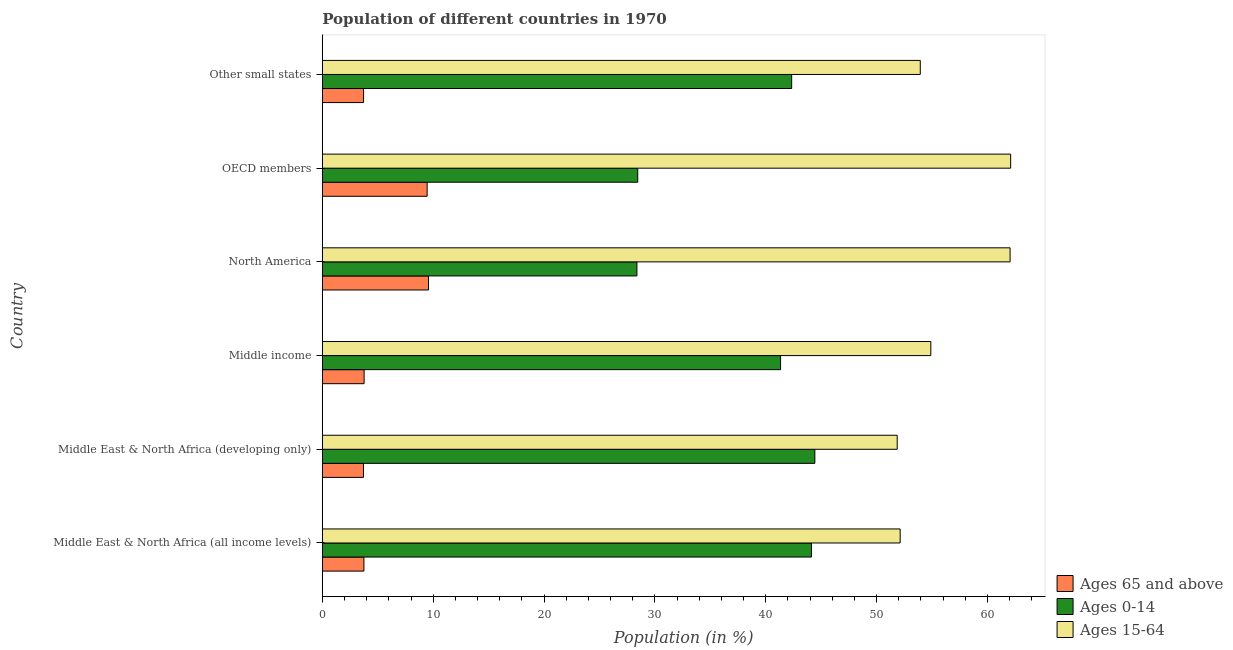How many different coloured bars are there?
Offer a terse response. 3. Are the number of bars on each tick of the Y-axis equal?
Offer a terse response. Yes. What is the label of the 3rd group of bars from the top?
Your response must be concise. North America. What is the percentage of population within the age-group 15-64 in Middle East & North Africa (all income levels)?
Your answer should be very brief. 52.13. Across all countries, what is the maximum percentage of population within the age-group 15-64?
Provide a short and direct response. 62.09. Across all countries, what is the minimum percentage of population within the age-group of 65 and above?
Your answer should be compact. 3.71. In which country was the percentage of population within the age-group of 65 and above minimum?
Provide a short and direct response. Middle East & North Africa (developing only). What is the total percentage of population within the age-group 15-64 in the graph?
Give a very brief answer. 336.96. What is the difference between the percentage of population within the age-group 0-14 in Middle East & North Africa (developing only) and that in North America?
Give a very brief answer. 16.05. What is the difference between the percentage of population within the age-group of 65 and above in Middle income and the percentage of population within the age-group 0-14 in North America?
Keep it short and to the point. -24.61. What is the average percentage of population within the age-group 15-64 per country?
Provide a succinct answer. 56.16. What is the difference between the percentage of population within the age-group of 65 and above and percentage of population within the age-group 0-14 in Other small states?
Provide a short and direct response. -38.62. What is the ratio of the percentage of population within the age-group 15-64 in Middle East & North Africa (all income levels) to that in OECD members?
Your answer should be very brief. 0.84. What is the difference between the highest and the second highest percentage of population within the age-group 15-64?
Provide a succinct answer. 0.05. What is the difference between the highest and the lowest percentage of population within the age-group 0-14?
Your answer should be compact. 16.05. In how many countries, is the percentage of population within the age-group of 65 and above greater than the average percentage of population within the age-group of 65 and above taken over all countries?
Provide a succinct answer. 2. Is the sum of the percentage of population within the age-group 0-14 in Middle East & North Africa (all income levels) and Middle East & North Africa (developing only) greater than the maximum percentage of population within the age-group of 65 and above across all countries?
Ensure brevity in your answer.  Yes. What does the 1st bar from the top in Other small states represents?
Provide a short and direct response. Ages 15-64. What does the 3rd bar from the bottom in Middle East & North Africa (developing only) represents?
Provide a succinct answer. Ages 15-64. Is it the case that in every country, the sum of the percentage of population within the age-group of 65 and above and percentage of population within the age-group 0-14 is greater than the percentage of population within the age-group 15-64?
Ensure brevity in your answer.  No. Are all the bars in the graph horizontal?
Provide a short and direct response. Yes. What is the difference between two consecutive major ticks on the X-axis?
Your answer should be very brief. 10. Does the graph contain any zero values?
Give a very brief answer. No. Where does the legend appear in the graph?
Provide a succinct answer. Bottom right. How many legend labels are there?
Your answer should be compact. 3. What is the title of the graph?
Your response must be concise. Population of different countries in 1970. What is the label or title of the X-axis?
Keep it short and to the point. Population (in %). What is the label or title of the Y-axis?
Make the answer very short. Country. What is the Population (in %) of Ages 65 and above in Middle East & North Africa (all income levels)?
Offer a very short reply. 3.75. What is the Population (in %) in Ages 0-14 in Middle East & North Africa (all income levels)?
Provide a short and direct response. 44.12. What is the Population (in %) in Ages 15-64 in Middle East & North Africa (all income levels)?
Keep it short and to the point. 52.13. What is the Population (in %) in Ages 65 and above in Middle East & North Africa (developing only)?
Give a very brief answer. 3.71. What is the Population (in %) in Ages 0-14 in Middle East & North Africa (developing only)?
Provide a short and direct response. 44.43. What is the Population (in %) in Ages 15-64 in Middle East & North Africa (developing only)?
Make the answer very short. 51.86. What is the Population (in %) in Ages 65 and above in Middle income?
Provide a short and direct response. 3.77. What is the Population (in %) in Ages 0-14 in Middle income?
Your answer should be very brief. 41.34. What is the Population (in %) in Ages 15-64 in Middle income?
Ensure brevity in your answer.  54.89. What is the Population (in %) of Ages 65 and above in North America?
Provide a short and direct response. 9.58. What is the Population (in %) of Ages 0-14 in North America?
Your response must be concise. 28.38. What is the Population (in %) of Ages 15-64 in North America?
Provide a succinct answer. 62.04. What is the Population (in %) in Ages 65 and above in OECD members?
Provide a succinct answer. 9.45. What is the Population (in %) in Ages 0-14 in OECD members?
Make the answer very short. 28.45. What is the Population (in %) in Ages 15-64 in OECD members?
Make the answer very short. 62.09. What is the Population (in %) of Ages 65 and above in Other small states?
Offer a very short reply. 3.72. What is the Population (in %) of Ages 0-14 in Other small states?
Give a very brief answer. 42.34. What is the Population (in %) of Ages 15-64 in Other small states?
Provide a short and direct response. 53.94. Across all countries, what is the maximum Population (in %) of Ages 65 and above?
Make the answer very short. 9.58. Across all countries, what is the maximum Population (in %) in Ages 0-14?
Keep it short and to the point. 44.43. Across all countries, what is the maximum Population (in %) of Ages 15-64?
Make the answer very short. 62.09. Across all countries, what is the minimum Population (in %) in Ages 65 and above?
Ensure brevity in your answer.  3.71. Across all countries, what is the minimum Population (in %) of Ages 0-14?
Ensure brevity in your answer.  28.38. Across all countries, what is the minimum Population (in %) of Ages 15-64?
Keep it short and to the point. 51.86. What is the total Population (in %) of Ages 65 and above in the graph?
Keep it short and to the point. 33.98. What is the total Population (in %) of Ages 0-14 in the graph?
Keep it short and to the point. 229.06. What is the total Population (in %) in Ages 15-64 in the graph?
Give a very brief answer. 336.96. What is the difference between the Population (in %) of Ages 65 and above in Middle East & North Africa (all income levels) and that in Middle East & North Africa (developing only)?
Provide a short and direct response. 0.04. What is the difference between the Population (in %) of Ages 0-14 in Middle East & North Africa (all income levels) and that in Middle East & North Africa (developing only)?
Offer a very short reply. -0.31. What is the difference between the Population (in %) in Ages 15-64 in Middle East & North Africa (all income levels) and that in Middle East & North Africa (developing only)?
Your answer should be very brief. 0.27. What is the difference between the Population (in %) of Ages 65 and above in Middle East & North Africa (all income levels) and that in Middle income?
Your answer should be compact. -0.02. What is the difference between the Population (in %) of Ages 0-14 in Middle East & North Africa (all income levels) and that in Middle income?
Ensure brevity in your answer.  2.79. What is the difference between the Population (in %) of Ages 15-64 in Middle East & North Africa (all income levels) and that in Middle income?
Ensure brevity in your answer.  -2.77. What is the difference between the Population (in %) in Ages 65 and above in Middle East & North Africa (all income levels) and that in North America?
Your response must be concise. -5.83. What is the difference between the Population (in %) in Ages 0-14 in Middle East & North Africa (all income levels) and that in North America?
Provide a succinct answer. 15.74. What is the difference between the Population (in %) in Ages 15-64 in Middle East & North Africa (all income levels) and that in North America?
Your response must be concise. -9.92. What is the difference between the Population (in %) of Ages 65 and above in Middle East & North Africa (all income levels) and that in OECD members?
Keep it short and to the point. -5.7. What is the difference between the Population (in %) of Ages 0-14 in Middle East & North Africa (all income levels) and that in OECD members?
Provide a short and direct response. 15.67. What is the difference between the Population (in %) in Ages 15-64 in Middle East & North Africa (all income levels) and that in OECD members?
Provide a short and direct response. -9.97. What is the difference between the Population (in %) of Ages 65 and above in Middle East & North Africa (all income levels) and that in Other small states?
Offer a very short reply. 0.03. What is the difference between the Population (in %) in Ages 0-14 in Middle East & North Africa (all income levels) and that in Other small states?
Ensure brevity in your answer.  1.78. What is the difference between the Population (in %) in Ages 15-64 in Middle East & North Africa (all income levels) and that in Other small states?
Offer a terse response. -1.82. What is the difference between the Population (in %) of Ages 65 and above in Middle East & North Africa (developing only) and that in Middle income?
Give a very brief answer. -0.06. What is the difference between the Population (in %) in Ages 0-14 in Middle East & North Africa (developing only) and that in Middle income?
Give a very brief answer. 3.09. What is the difference between the Population (in %) in Ages 15-64 in Middle East & North Africa (developing only) and that in Middle income?
Your answer should be very brief. -3.03. What is the difference between the Population (in %) in Ages 65 and above in Middle East & North Africa (developing only) and that in North America?
Ensure brevity in your answer.  -5.87. What is the difference between the Population (in %) of Ages 0-14 in Middle East & North Africa (developing only) and that in North America?
Provide a short and direct response. 16.05. What is the difference between the Population (in %) of Ages 15-64 in Middle East & North Africa (developing only) and that in North America?
Provide a short and direct response. -10.18. What is the difference between the Population (in %) in Ages 65 and above in Middle East & North Africa (developing only) and that in OECD members?
Keep it short and to the point. -5.74. What is the difference between the Population (in %) of Ages 0-14 in Middle East & North Africa (developing only) and that in OECD members?
Your answer should be compact. 15.98. What is the difference between the Population (in %) of Ages 15-64 in Middle East & North Africa (developing only) and that in OECD members?
Your answer should be compact. -10.23. What is the difference between the Population (in %) of Ages 65 and above in Middle East & North Africa (developing only) and that in Other small states?
Your answer should be compact. -0.01. What is the difference between the Population (in %) in Ages 0-14 in Middle East & North Africa (developing only) and that in Other small states?
Make the answer very short. 2.09. What is the difference between the Population (in %) in Ages 15-64 in Middle East & North Africa (developing only) and that in Other small states?
Provide a succinct answer. -2.08. What is the difference between the Population (in %) of Ages 65 and above in Middle income and that in North America?
Keep it short and to the point. -5.81. What is the difference between the Population (in %) of Ages 0-14 in Middle income and that in North America?
Offer a very short reply. 12.96. What is the difference between the Population (in %) in Ages 15-64 in Middle income and that in North America?
Give a very brief answer. -7.15. What is the difference between the Population (in %) in Ages 65 and above in Middle income and that in OECD members?
Your answer should be compact. -5.68. What is the difference between the Population (in %) in Ages 0-14 in Middle income and that in OECD members?
Offer a terse response. 12.89. What is the difference between the Population (in %) of Ages 15-64 in Middle income and that in OECD members?
Your response must be concise. -7.2. What is the difference between the Population (in %) of Ages 65 and above in Middle income and that in Other small states?
Your answer should be very brief. 0.05. What is the difference between the Population (in %) of Ages 0-14 in Middle income and that in Other small states?
Make the answer very short. -1. What is the difference between the Population (in %) of Ages 15-64 in Middle income and that in Other small states?
Provide a succinct answer. 0.95. What is the difference between the Population (in %) in Ages 65 and above in North America and that in OECD members?
Give a very brief answer. 0.12. What is the difference between the Population (in %) of Ages 0-14 in North America and that in OECD members?
Offer a terse response. -0.07. What is the difference between the Population (in %) of Ages 15-64 in North America and that in OECD members?
Offer a terse response. -0.05. What is the difference between the Population (in %) in Ages 65 and above in North America and that in Other small states?
Your response must be concise. 5.86. What is the difference between the Population (in %) in Ages 0-14 in North America and that in Other small states?
Keep it short and to the point. -13.96. What is the difference between the Population (in %) of Ages 15-64 in North America and that in Other small states?
Your response must be concise. 8.1. What is the difference between the Population (in %) of Ages 65 and above in OECD members and that in Other small states?
Ensure brevity in your answer.  5.74. What is the difference between the Population (in %) of Ages 0-14 in OECD members and that in Other small states?
Provide a succinct answer. -13.89. What is the difference between the Population (in %) of Ages 15-64 in OECD members and that in Other small states?
Offer a very short reply. 8.15. What is the difference between the Population (in %) in Ages 65 and above in Middle East & North Africa (all income levels) and the Population (in %) in Ages 0-14 in Middle East & North Africa (developing only)?
Offer a very short reply. -40.68. What is the difference between the Population (in %) in Ages 65 and above in Middle East & North Africa (all income levels) and the Population (in %) in Ages 15-64 in Middle East & North Africa (developing only)?
Provide a short and direct response. -48.11. What is the difference between the Population (in %) in Ages 0-14 in Middle East & North Africa (all income levels) and the Population (in %) in Ages 15-64 in Middle East & North Africa (developing only)?
Give a very brief answer. -7.74. What is the difference between the Population (in %) of Ages 65 and above in Middle East & North Africa (all income levels) and the Population (in %) of Ages 0-14 in Middle income?
Offer a very short reply. -37.59. What is the difference between the Population (in %) of Ages 65 and above in Middle East & North Africa (all income levels) and the Population (in %) of Ages 15-64 in Middle income?
Offer a very short reply. -51.14. What is the difference between the Population (in %) of Ages 0-14 in Middle East & North Africa (all income levels) and the Population (in %) of Ages 15-64 in Middle income?
Offer a very short reply. -10.77. What is the difference between the Population (in %) in Ages 65 and above in Middle East & North Africa (all income levels) and the Population (in %) in Ages 0-14 in North America?
Keep it short and to the point. -24.63. What is the difference between the Population (in %) in Ages 65 and above in Middle East & North Africa (all income levels) and the Population (in %) in Ages 15-64 in North America?
Your response must be concise. -58.29. What is the difference between the Population (in %) in Ages 0-14 in Middle East & North Africa (all income levels) and the Population (in %) in Ages 15-64 in North America?
Make the answer very short. -17.92. What is the difference between the Population (in %) in Ages 65 and above in Middle East & North Africa (all income levels) and the Population (in %) in Ages 0-14 in OECD members?
Offer a very short reply. -24.7. What is the difference between the Population (in %) of Ages 65 and above in Middle East & North Africa (all income levels) and the Population (in %) of Ages 15-64 in OECD members?
Your answer should be compact. -58.34. What is the difference between the Population (in %) of Ages 0-14 in Middle East & North Africa (all income levels) and the Population (in %) of Ages 15-64 in OECD members?
Offer a very short reply. -17.97. What is the difference between the Population (in %) in Ages 65 and above in Middle East & North Africa (all income levels) and the Population (in %) in Ages 0-14 in Other small states?
Offer a very short reply. -38.59. What is the difference between the Population (in %) of Ages 65 and above in Middle East & North Africa (all income levels) and the Population (in %) of Ages 15-64 in Other small states?
Give a very brief answer. -50.19. What is the difference between the Population (in %) of Ages 0-14 in Middle East & North Africa (all income levels) and the Population (in %) of Ages 15-64 in Other small states?
Ensure brevity in your answer.  -9.82. What is the difference between the Population (in %) in Ages 65 and above in Middle East & North Africa (developing only) and the Population (in %) in Ages 0-14 in Middle income?
Your response must be concise. -37.63. What is the difference between the Population (in %) of Ages 65 and above in Middle East & North Africa (developing only) and the Population (in %) of Ages 15-64 in Middle income?
Offer a terse response. -51.18. What is the difference between the Population (in %) of Ages 0-14 in Middle East & North Africa (developing only) and the Population (in %) of Ages 15-64 in Middle income?
Offer a terse response. -10.46. What is the difference between the Population (in %) in Ages 65 and above in Middle East & North Africa (developing only) and the Population (in %) in Ages 0-14 in North America?
Offer a terse response. -24.67. What is the difference between the Population (in %) in Ages 65 and above in Middle East & North Africa (developing only) and the Population (in %) in Ages 15-64 in North America?
Offer a very short reply. -58.33. What is the difference between the Population (in %) of Ages 0-14 in Middle East & North Africa (developing only) and the Population (in %) of Ages 15-64 in North America?
Give a very brief answer. -17.61. What is the difference between the Population (in %) in Ages 65 and above in Middle East & North Africa (developing only) and the Population (in %) in Ages 0-14 in OECD members?
Keep it short and to the point. -24.74. What is the difference between the Population (in %) of Ages 65 and above in Middle East & North Africa (developing only) and the Population (in %) of Ages 15-64 in OECD members?
Offer a very short reply. -58.38. What is the difference between the Population (in %) in Ages 0-14 in Middle East & North Africa (developing only) and the Population (in %) in Ages 15-64 in OECD members?
Provide a short and direct response. -17.66. What is the difference between the Population (in %) of Ages 65 and above in Middle East & North Africa (developing only) and the Population (in %) of Ages 0-14 in Other small states?
Ensure brevity in your answer.  -38.63. What is the difference between the Population (in %) in Ages 65 and above in Middle East & North Africa (developing only) and the Population (in %) in Ages 15-64 in Other small states?
Your response must be concise. -50.23. What is the difference between the Population (in %) of Ages 0-14 in Middle East & North Africa (developing only) and the Population (in %) of Ages 15-64 in Other small states?
Make the answer very short. -9.51. What is the difference between the Population (in %) of Ages 65 and above in Middle income and the Population (in %) of Ages 0-14 in North America?
Ensure brevity in your answer.  -24.61. What is the difference between the Population (in %) of Ages 65 and above in Middle income and the Population (in %) of Ages 15-64 in North America?
Provide a succinct answer. -58.27. What is the difference between the Population (in %) in Ages 0-14 in Middle income and the Population (in %) in Ages 15-64 in North America?
Ensure brevity in your answer.  -20.71. What is the difference between the Population (in %) of Ages 65 and above in Middle income and the Population (in %) of Ages 0-14 in OECD members?
Your response must be concise. -24.68. What is the difference between the Population (in %) of Ages 65 and above in Middle income and the Population (in %) of Ages 15-64 in OECD members?
Provide a short and direct response. -58.32. What is the difference between the Population (in %) in Ages 0-14 in Middle income and the Population (in %) in Ages 15-64 in OECD members?
Your response must be concise. -20.76. What is the difference between the Population (in %) of Ages 65 and above in Middle income and the Population (in %) of Ages 0-14 in Other small states?
Your answer should be very brief. -38.57. What is the difference between the Population (in %) of Ages 65 and above in Middle income and the Population (in %) of Ages 15-64 in Other small states?
Make the answer very short. -50.17. What is the difference between the Population (in %) in Ages 0-14 in Middle income and the Population (in %) in Ages 15-64 in Other small states?
Offer a terse response. -12.6. What is the difference between the Population (in %) of Ages 65 and above in North America and the Population (in %) of Ages 0-14 in OECD members?
Your answer should be compact. -18.87. What is the difference between the Population (in %) in Ages 65 and above in North America and the Population (in %) in Ages 15-64 in OECD members?
Give a very brief answer. -52.52. What is the difference between the Population (in %) in Ages 0-14 in North America and the Population (in %) in Ages 15-64 in OECD members?
Keep it short and to the point. -33.71. What is the difference between the Population (in %) in Ages 65 and above in North America and the Population (in %) in Ages 0-14 in Other small states?
Provide a succinct answer. -32.76. What is the difference between the Population (in %) of Ages 65 and above in North America and the Population (in %) of Ages 15-64 in Other small states?
Make the answer very short. -44.36. What is the difference between the Population (in %) in Ages 0-14 in North America and the Population (in %) in Ages 15-64 in Other small states?
Provide a short and direct response. -25.56. What is the difference between the Population (in %) of Ages 65 and above in OECD members and the Population (in %) of Ages 0-14 in Other small states?
Provide a succinct answer. -32.89. What is the difference between the Population (in %) in Ages 65 and above in OECD members and the Population (in %) in Ages 15-64 in Other small states?
Make the answer very short. -44.49. What is the difference between the Population (in %) of Ages 0-14 in OECD members and the Population (in %) of Ages 15-64 in Other small states?
Provide a short and direct response. -25.49. What is the average Population (in %) of Ages 65 and above per country?
Give a very brief answer. 5.66. What is the average Population (in %) in Ages 0-14 per country?
Make the answer very short. 38.18. What is the average Population (in %) in Ages 15-64 per country?
Offer a very short reply. 56.16. What is the difference between the Population (in %) of Ages 65 and above and Population (in %) of Ages 0-14 in Middle East & North Africa (all income levels)?
Offer a terse response. -40.37. What is the difference between the Population (in %) of Ages 65 and above and Population (in %) of Ages 15-64 in Middle East & North Africa (all income levels)?
Make the answer very short. -48.38. What is the difference between the Population (in %) of Ages 0-14 and Population (in %) of Ages 15-64 in Middle East & North Africa (all income levels)?
Make the answer very short. -8. What is the difference between the Population (in %) of Ages 65 and above and Population (in %) of Ages 0-14 in Middle East & North Africa (developing only)?
Provide a short and direct response. -40.72. What is the difference between the Population (in %) in Ages 65 and above and Population (in %) in Ages 15-64 in Middle East & North Africa (developing only)?
Keep it short and to the point. -48.15. What is the difference between the Population (in %) in Ages 0-14 and Population (in %) in Ages 15-64 in Middle East & North Africa (developing only)?
Offer a very short reply. -7.43. What is the difference between the Population (in %) of Ages 65 and above and Population (in %) of Ages 0-14 in Middle income?
Provide a short and direct response. -37.57. What is the difference between the Population (in %) in Ages 65 and above and Population (in %) in Ages 15-64 in Middle income?
Your answer should be compact. -51.12. What is the difference between the Population (in %) of Ages 0-14 and Population (in %) of Ages 15-64 in Middle income?
Make the answer very short. -13.56. What is the difference between the Population (in %) of Ages 65 and above and Population (in %) of Ages 0-14 in North America?
Provide a short and direct response. -18.8. What is the difference between the Population (in %) in Ages 65 and above and Population (in %) in Ages 15-64 in North America?
Provide a succinct answer. -52.47. What is the difference between the Population (in %) of Ages 0-14 and Population (in %) of Ages 15-64 in North America?
Offer a very short reply. -33.66. What is the difference between the Population (in %) of Ages 65 and above and Population (in %) of Ages 0-14 in OECD members?
Give a very brief answer. -19. What is the difference between the Population (in %) in Ages 65 and above and Population (in %) in Ages 15-64 in OECD members?
Your response must be concise. -52.64. What is the difference between the Population (in %) of Ages 0-14 and Population (in %) of Ages 15-64 in OECD members?
Your answer should be compact. -33.64. What is the difference between the Population (in %) of Ages 65 and above and Population (in %) of Ages 0-14 in Other small states?
Give a very brief answer. -38.62. What is the difference between the Population (in %) in Ages 65 and above and Population (in %) in Ages 15-64 in Other small states?
Ensure brevity in your answer.  -50.22. What is the difference between the Population (in %) of Ages 0-14 and Population (in %) of Ages 15-64 in Other small states?
Keep it short and to the point. -11.6. What is the ratio of the Population (in %) in Ages 65 and above in Middle East & North Africa (all income levels) to that in Middle East & North Africa (developing only)?
Your answer should be very brief. 1.01. What is the ratio of the Population (in %) of Ages 0-14 in Middle East & North Africa (all income levels) to that in Middle income?
Give a very brief answer. 1.07. What is the ratio of the Population (in %) in Ages 15-64 in Middle East & North Africa (all income levels) to that in Middle income?
Your answer should be very brief. 0.95. What is the ratio of the Population (in %) in Ages 65 and above in Middle East & North Africa (all income levels) to that in North America?
Provide a short and direct response. 0.39. What is the ratio of the Population (in %) in Ages 0-14 in Middle East & North Africa (all income levels) to that in North America?
Your response must be concise. 1.55. What is the ratio of the Population (in %) in Ages 15-64 in Middle East & North Africa (all income levels) to that in North America?
Offer a terse response. 0.84. What is the ratio of the Population (in %) in Ages 65 and above in Middle East & North Africa (all income levels) to that in OECD members?
Your response must be concise. 0.4. What is the ratio of the Population (in %) in Ages 0-14 in Middle East & North Africa (all income levels) to that in OECD members?
Your response must be concise. 1.55. What is the ratio of the Population (in %) in Ages 15-64 in Middle East & North Africa (all income levels) to that in OECD members?
Offer a terse response. 0.84. What is the ratio of the Population (in %) of Ages 65 and above in Middle East & North Africa (all income levels) to that in Other small states?
Your answer should be compact. 1.01. What is the ratio of the Population (in %) in Ages 0-14 in Middle East & North Africa (all income levels) to that in Other small states?
Your answer should be very brief. 1.04. What is the ratio of the Population (in %) in Ages 15-64 in Middle East & North Africa (all income levels) to that in Other small states?
Make the answer very short. 0.97. What is the ratio of the Population (in %) in Ages 65 and above in Middle East & North Africa (developing only) to that in Middle income?
Your answer should be very brief. 0.98. What is the ratio of the Population (in %) of Ages 0-14 in Middle East & North Africa (developing only) to that in Middle income?
Your answer should be compact. 1.07. What is the ratio of the Population (in %) in Ages 15-64 in Middle East & North Africa (developing only) to that in Middle income?
Provide a short and direct response. 0.94. What is the ratio of the Population (in %) in Ages 65 and above in Middle East & North Africa (developing only) to that in North America?
Offer a very short reply. 0.39. What is the ratio of the Population (in %) in Ages 0-14 in Middle East & North Africa (developing only) to that in North America?
Give a very brief answer. 1.57. What is the ratio of the Population (in %) in Ages 15-64 in Middle East & North Africa (developing only) to that in North America?
Keep it short and to the point. 0.84. What is the ratio of the Population (in %) in Ages 65 and above in Middle East & North Africa (developing only) to that in OECD members?
Provide a succinct answer. 0.39. What is the ratio of the Population (in %) in Ages 0-14 in Middle East & North Africa (developing only) to that in OECD members?
Your response must be concise. 1.56. What is the ratio of the Population (in %) in Ages 15-64 in Middle East & North Africa (developing only) to that in OECD members?
Your answer should be very brief. 0.84. What is the ratio of the Population (in %) of Ages 65 and above in Middle East & North Africa (developing only) to that in Other small states?
Your answer should be compact. 1. What is the ratio of the Population (in %) of Ages 0-14 in Middle East & North Africa (developing only) to that in Other small states?
Your answer should be compact. 1.05. What is the ratio of the Population (in %) of Ages 15-64 in Middle East & North Africa (developing only) to that in Other small states?
Your answer should be compact. 0.96. What is the ratio of the Population (in %) in Ages 65 and above in Middle income to that in North America?
Offer a very short reply. 0.39. What is the ratio of the Population (in %) of Ages 0-14 in Middle income to that in North America?
Your answer should be very brief. 1.46. What is the ratio of the Population (in %) of Ages 15-64 in Middle income to that in North America?
Offer a terse response. 0.88. What is the ratio of the Population (in %) of Ages 65 and above in Middle income to that in OECD members?
Keep it short and to the point. 0.4. What is the ratio of the Population (in %) of Ages 0-14 in Middle income to that in OECD members?
Ensure brevity in your answer.  1.45. What is the ratio of the Population (in %) of Ages 15-64 in Middle income to that in OECD members?
Your answer should be very brief. 0.88. What is the ratio of the Population (in %) of Ages 65 and above in Middle income to that in Other small states?
Your answer should be very brief. 1.01. What is the ratio of the Population (in %) in Ages 0-14 in Middle income to that in Other small states?
Your answer should be compact. 0.98. What is the ratio of the Population (in %) in Ages 15-64 in Middle income to that in Other small states?
Offer a very short reply. 1.02. What is the ratio of the Population (in %) of Ages 65 and above in North America to that in OECD members?
Provide a short and direct response. 1.01. What is the ratio of the Population (in %) in Ages 0-14 in North America to that in OECD members?
Give a very brief answer. 1. What is the ratio of the Population (in %) of Ages 65 and above in North America to that in Other small states?
Ensure brevity in your answer.  2.58. What is the ratio of the Population (in %) in Ages 0-14 in North America to that in Other small states?
Provide a short and direct response. 0.67. What is the ratio of the Population (in %) of Ages 15-64 in North America to that in Other small states?
Provide a succinct answer. 1.15. What is the ratio of the Population (in %) in Ages 65 and above in OECD members to that in Other small states?
Your answer should be compact. 2.54. What is the ratio of the Population (in %) in Ages 0-14 in OECD members to that in Other small states?
Provide a short and direct response. 0.67. What is the ratio of the Population (in %) in Ages 15-64 in OECD members to that in Other small states?
Give a very brief answer. 1.15. What is the difference between the highest and the second highest Population (in %) of Ages 65 and above?
Make the answer very short. 0.12. What is the difference between the highest and the second highest Population (in %) of Ages 0-14?
Keep it short and to the point. 0.31. What is the difference between the highest and the second highest Population (in %) of Ages 15-64?
Give a very brief answer. 0.05. What is the difference between the highest and the lowest Population (in %) in Ages 65 and above?
Keep it short and to the point. 5.87. What is the difference between the highest and the lowest Population (in %) in Ages 0-14?
Keep it short and to the point. 16.05. What is the difference between the highest and the lowest Population (in %) in Ages 15-64?
Your answer should be compact. 10.23. 